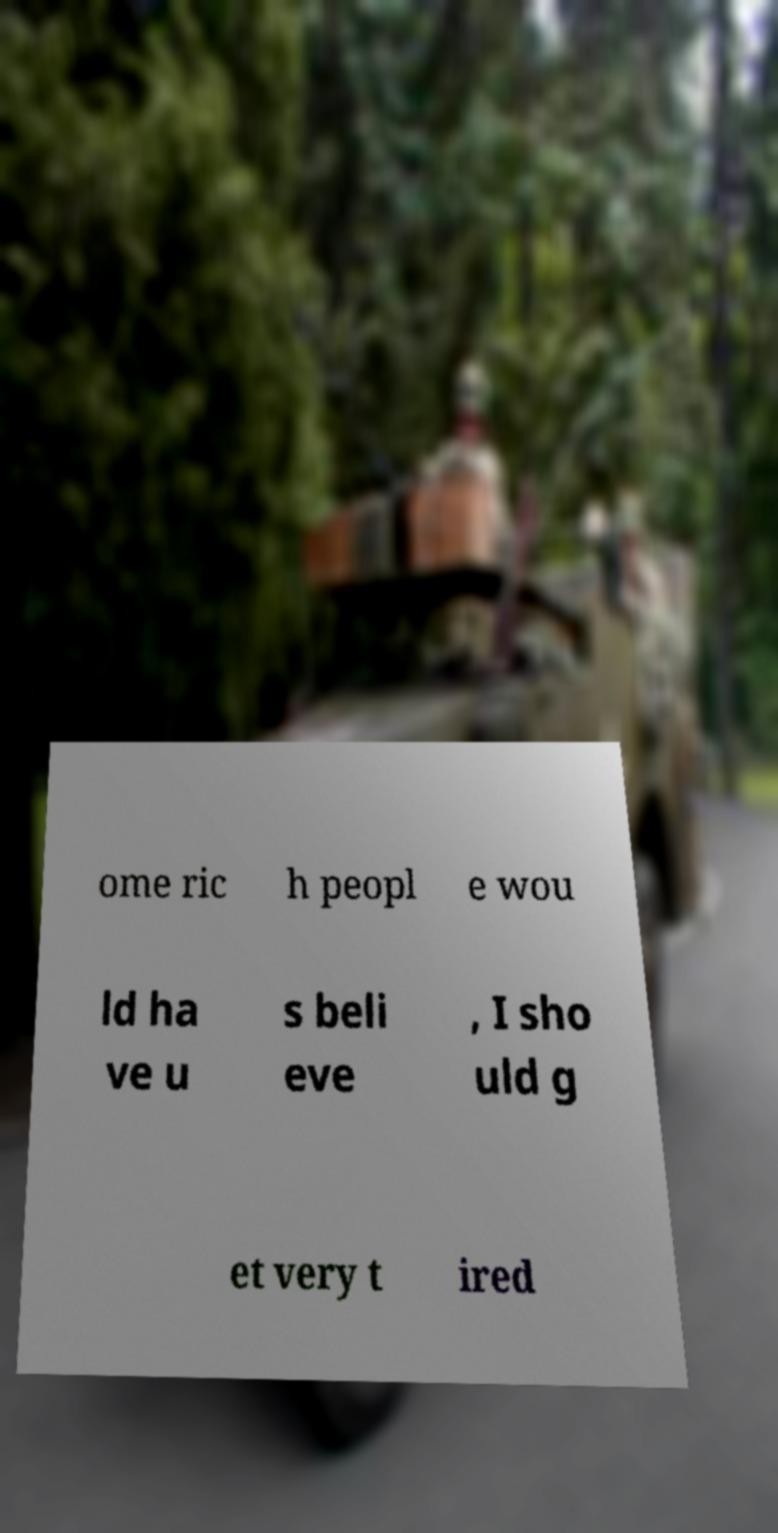Could you assist in decoding the text presented in this image and type it out clearly? ome ric h peopl e wou ld ha ve u s beli eve , I sho uld g et very t ired 